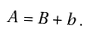Convert formula to latex. <formula><loc_0><loc_0><loc_500><loc_500>A = B + b \, .</formula> 